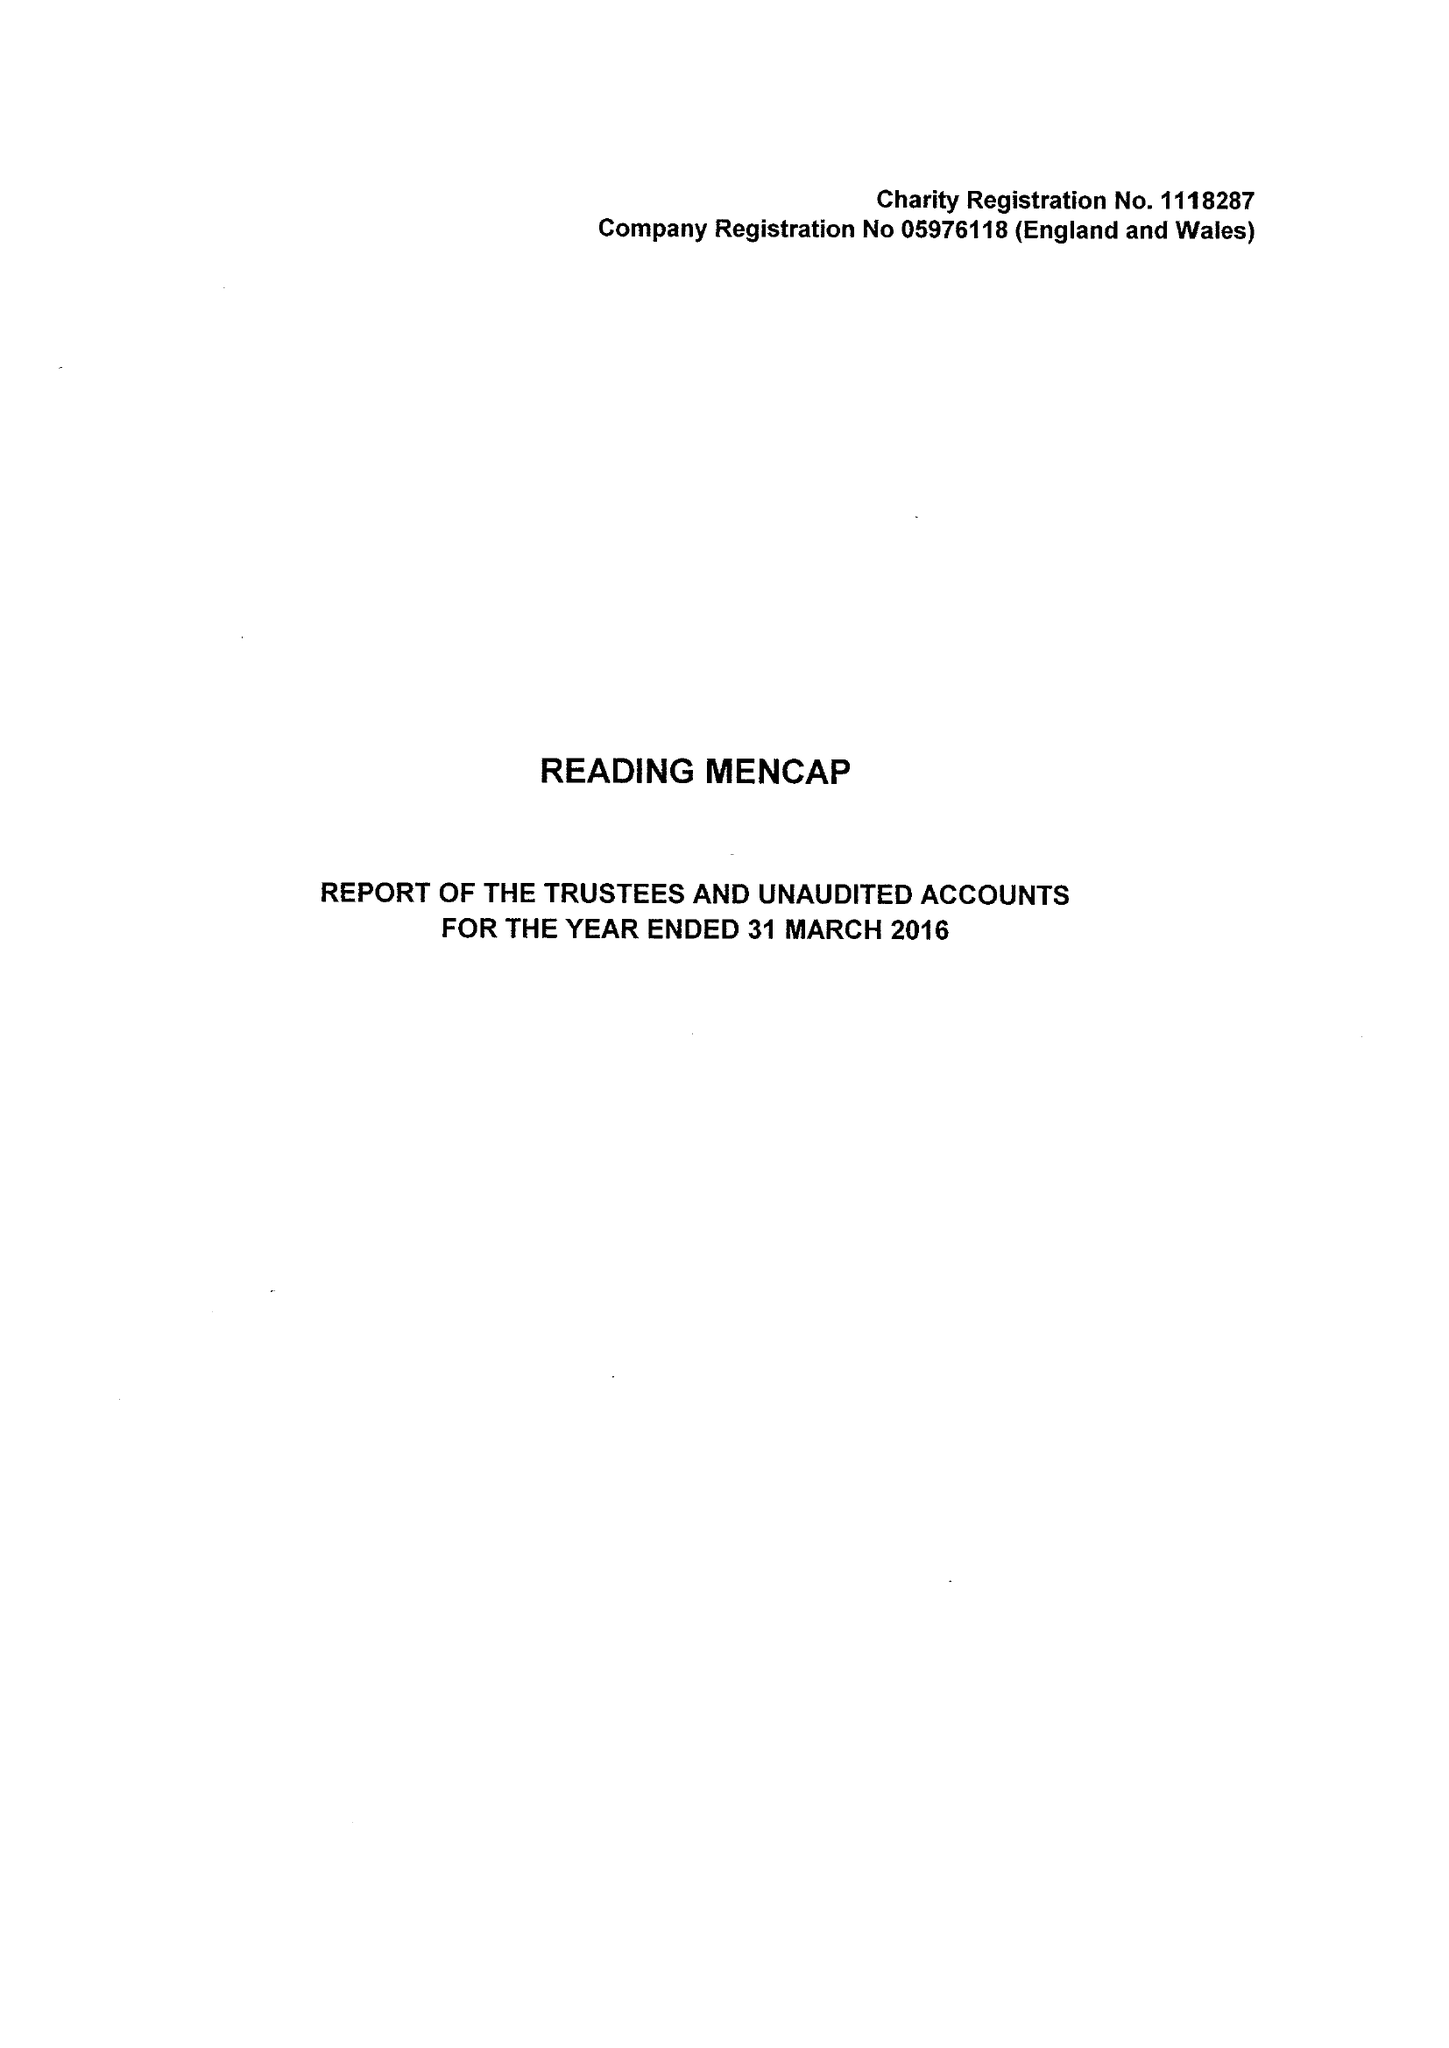What is the value for the charity_name?
Answer the question using a single word or phrase. Reading Mencap 